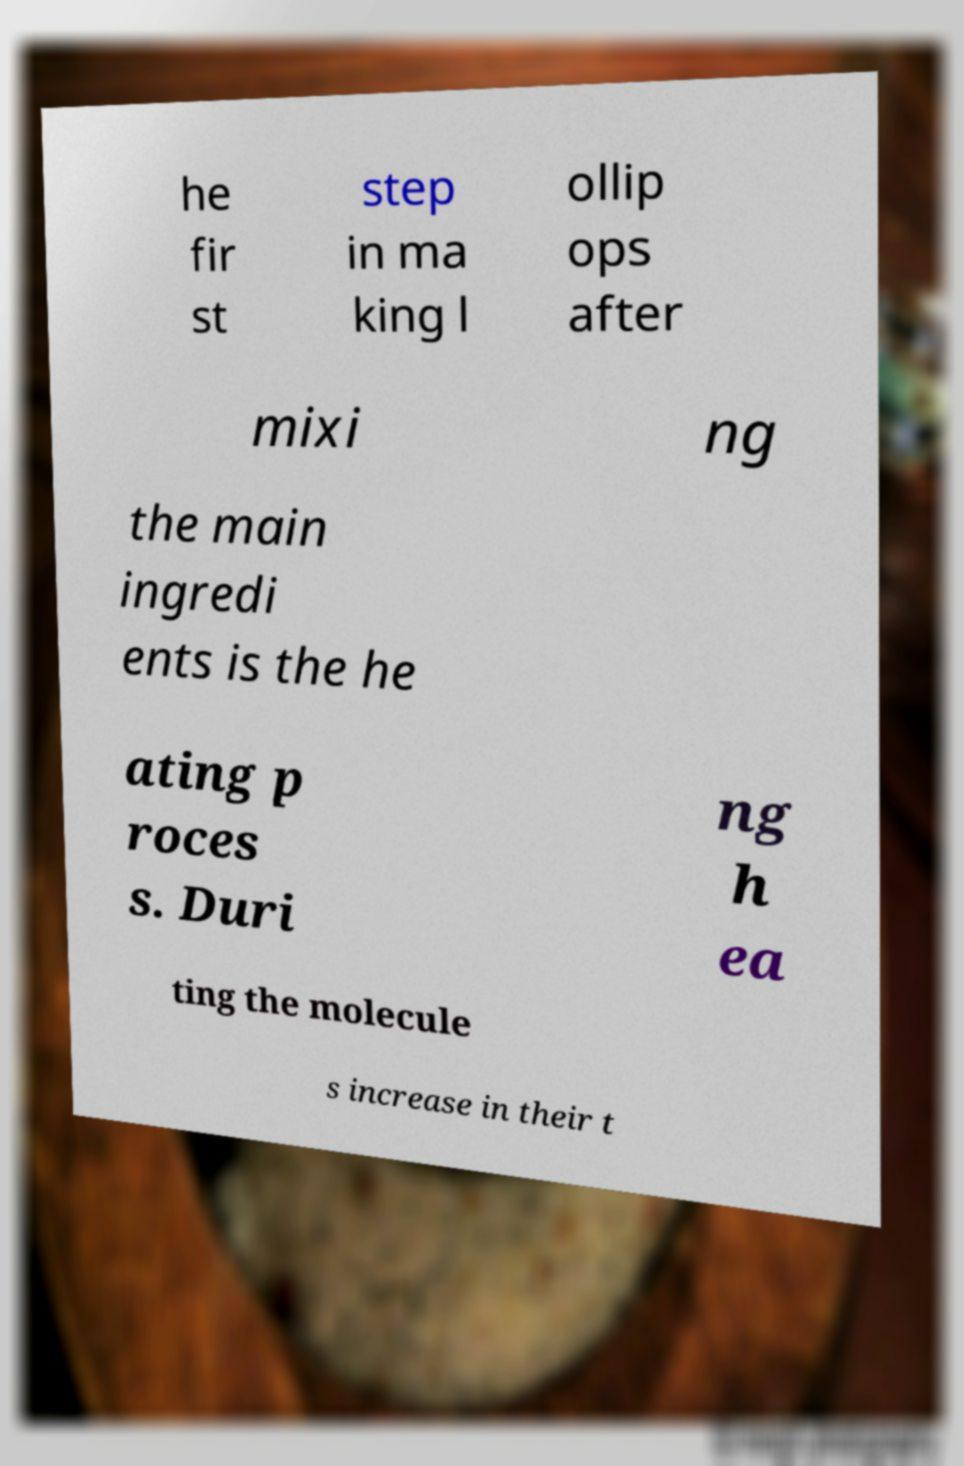What messages or text are displayed in this image? I need them in a readable, typed format. he fir st step in ma king l ollip ops after mixi ng the main ingredi ents is the he ating p roces s. Duri ng h ea ting the molecule s increase in their t 